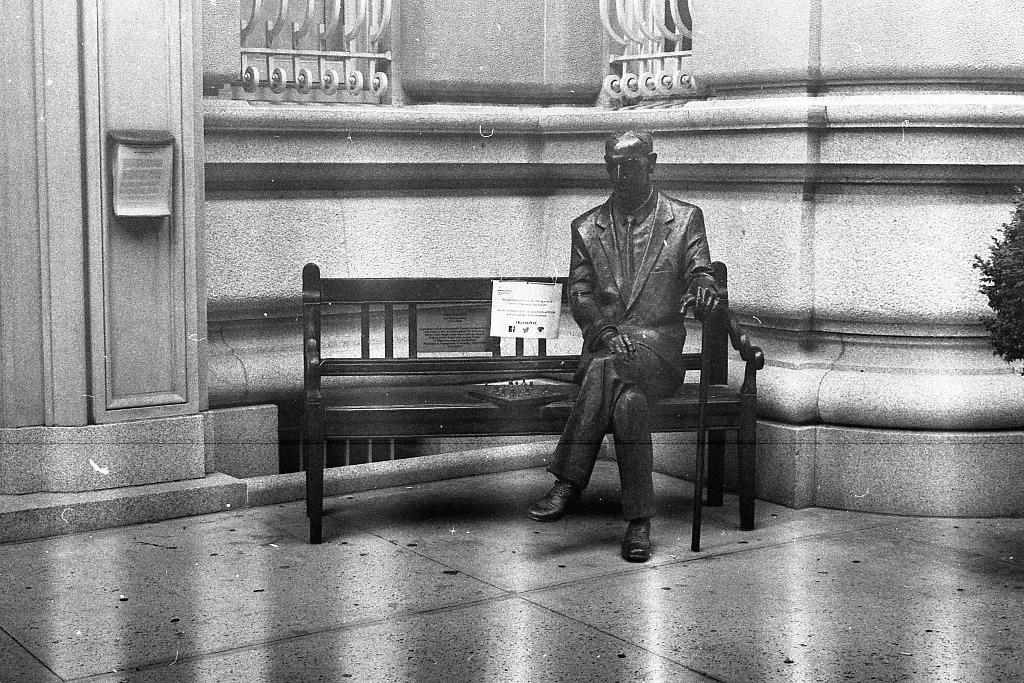What is the main subject of the image? There is a sculpture in the image. Where is the sculpture located? The sculpture is sitting on a bench. What can be seen in the background of the image? There is a building in the background of the image. What type of vegetation is on the right side of the image? There is a tree on the right side of the image. Can you describe the disgusting smell coming from the ocean in the image? There is no ocean present in the image, so it is not possible to describe a smell coming from it. 